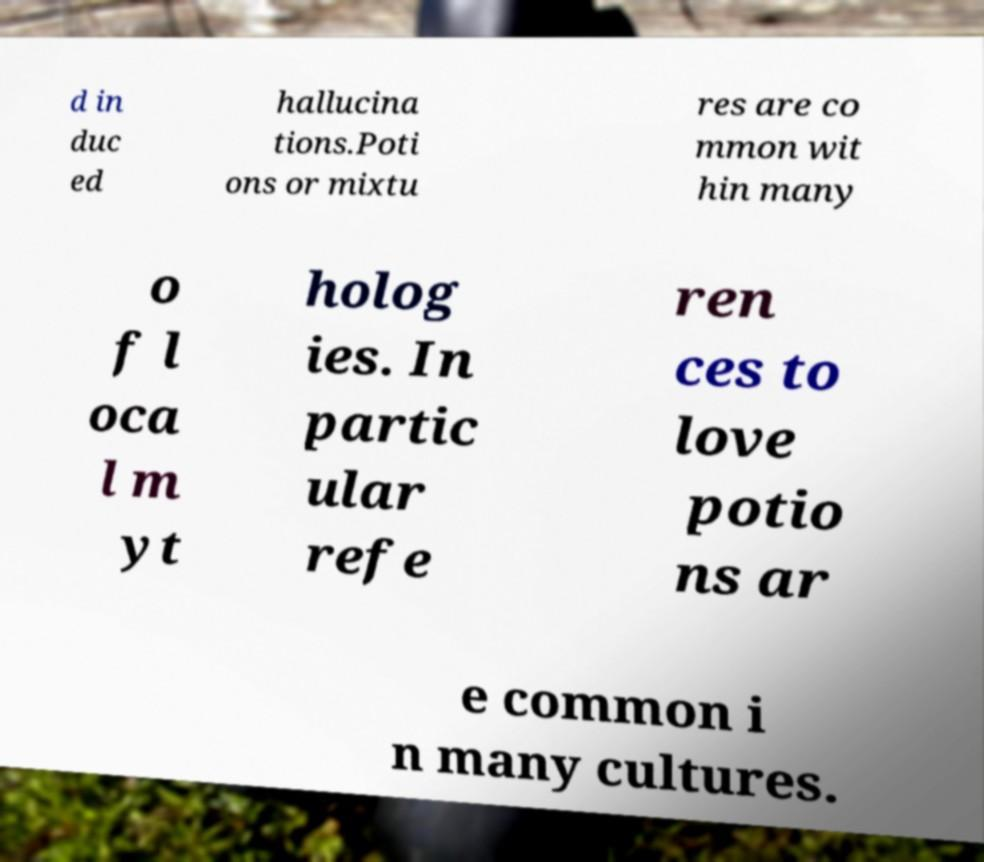Could you assist in decoding the text presented in this image and type it out clearly? d in duc ed hallucina tions.Poti ons or mixtu res are co mmon wit hin many o f l oca l m yt holog ies. In partic ular refe ren ces to love potio ns ar e common i n many cultures. 